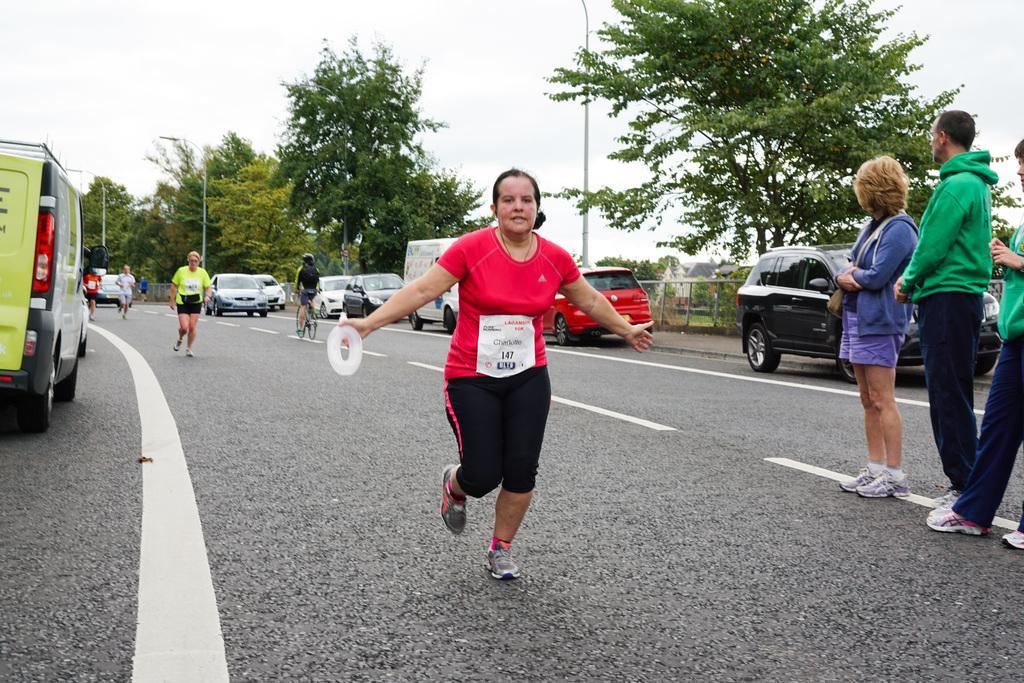In one or two sentences, can you explain what this image depicts? In this image there is a road on that road people are running and few are standing, on either side of the road there are cars, in the background there are trees and poles. 